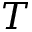Convert formula to latex. <formula><loc_0><loc_0><loc_500><loc_500>T</formula> 